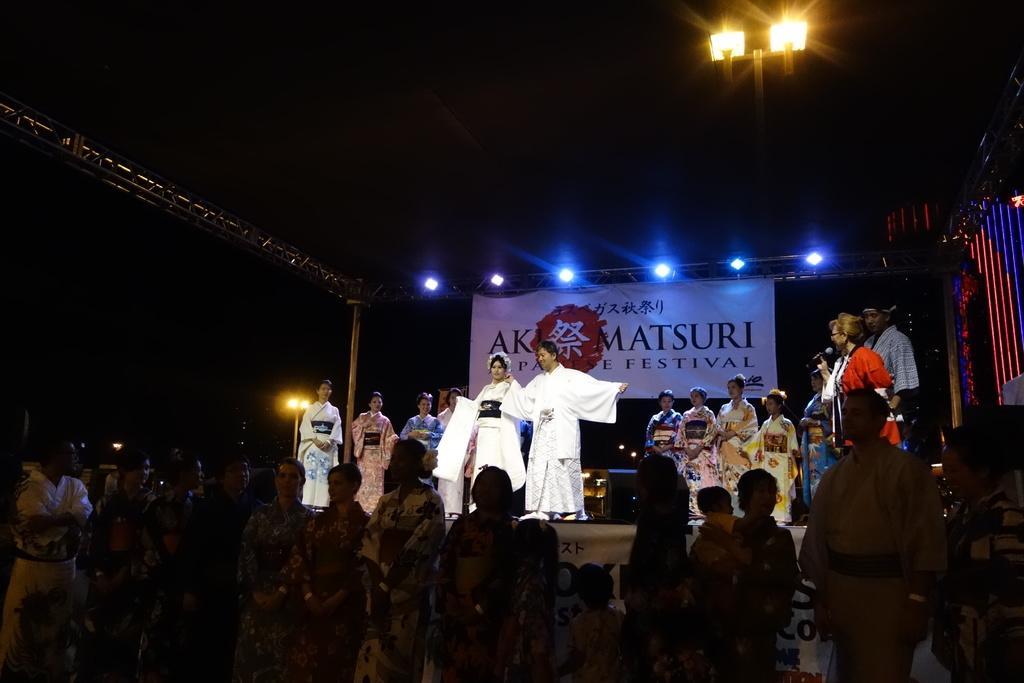Could you give a brief overview of what you see in this image? In this picture, I see few people standing on the dais and a woman holding a microphone on the right side and few people standing on the ground and i see few lights on the top and a banner on the back with some text on it. 